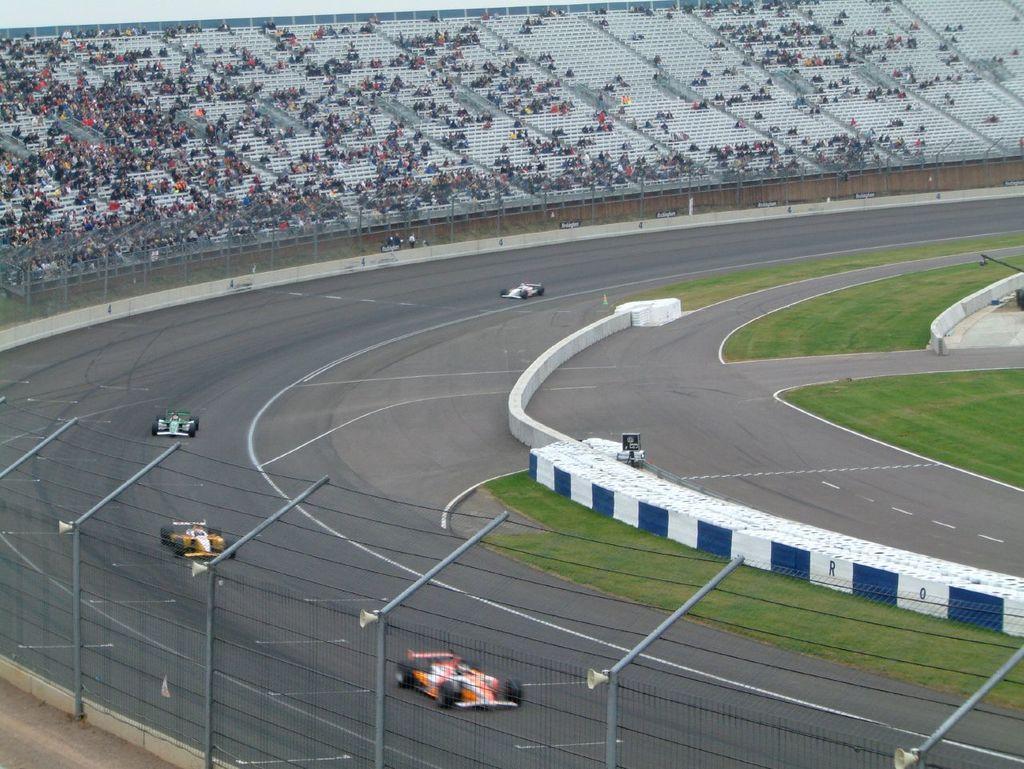Could you give a brief overview of what you see in this image? In this picture I can see there is a road and there are few cars moving on the road. There is grass, a fence and there are some empty chairs and few audience sitting here. 